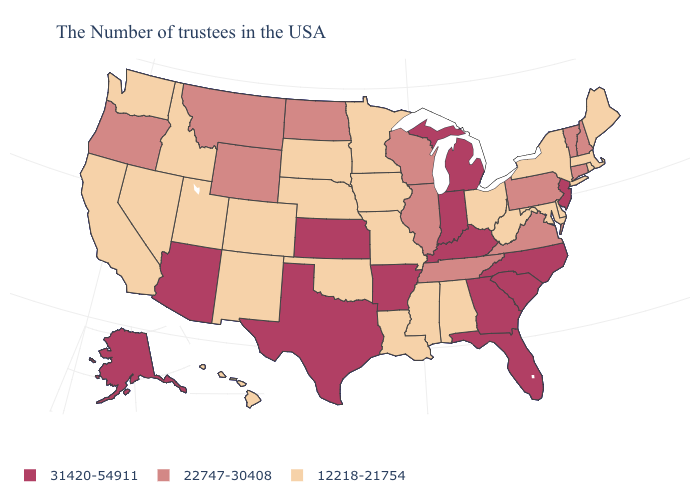Does the first symbol in the legend represent the smallest category?
Answer briefly. No. What is the value of Connecticut?
Answer briefly. 22747-30408. Among the states that border Florida , does Georgia have the highest value?
Answer briefly. Yes. What is the value of Rhode Island?
Be succinct. 12218-21754. What is the highest value in the USA?
Be succinct. 31420-54911. Which states have the highest value in the USA?
Answer briefly. New Jersey, North Carolina, South Carolina, Florida, Georgia, Michigan, Kentucky, Indiana, Arkansas, Kansas, Texas, Arizona, Alaska. Name the states that have a value in the range 31420-54911?
Write a very short answer. New Jersey, North Carolina, South Carolina, Florida, Georgia, Michigan, Kentucky, Indiana, Arkansas, Kansas, Texas, Arizona, Alaska. What is the value of Iowa?
Short answer required. 12218-21754. What is the highest value in the South ?
Write a very short answer. 31420-54911. What is the value of New Jersey?
Quick response, please. 31420-54911. What is the value of Idaho?
Quick response, please. 12218-21754. What is the value of South Dakota?
Keep it brief. 12218-21754. Does Delaware have a higher value than West Virginia?
Be succinct. No. Name the states that have a value in the range 31420-54911?
Be succinct. New Jersey, North Carolina, South Carolina, Florida, Georgia, Michigan, Kentucky, Indiana, Arkansas, Kansas, Texas, Arizona, Alaska. What is the value of South Dakota?
Be succinct. 12218-21754. 